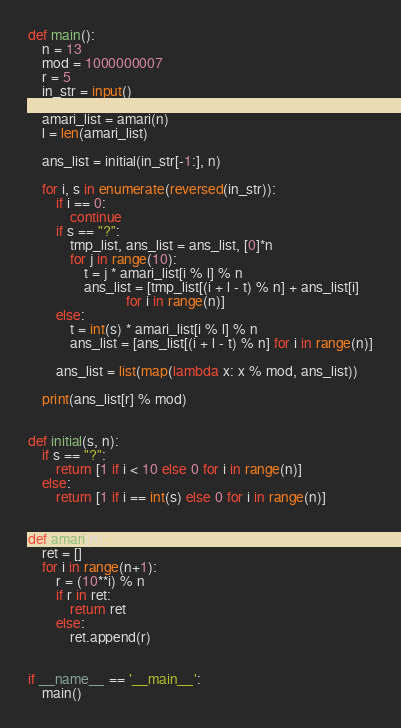Convert code to text. <code><loc_0><loc_0><loc_500><loc_500><_Python_>def main():
    n = 13
    mod = 1000000007
    r = 5
    in_str = input()

    amari_list = amari(n)
    l = len(amari_list)

    ans_list = initial(in_str[-1:], n)

    for i, s in enumerate(reversed(in_str)):
        if i == 0:
            continue
        if s == "?":
            tmp_list, ans_list = ans_list, [0]*n
            for j in range(10):
                t = j * amari_list[i % l] % n
                ans_list = [tmp_list[(i + l - t) % n] + ans_list[i]
                            for i in range(n)]
        else:
            t = int(s) * amari_list[i % l] % n
            ans_list = [ans_list[(i + l - t) % n] for i in range(n)]

        ans_list = list(map(lambda x: x % mod, ans_list))

    print(ans_list[r] % mod)


def initial(s, n):
    if s == "?":
        return [1 if i < 10 else 0 for i in range(n)]
    else:
        return [1 if i == int(s) else 0 for i in range(n)]


def amari(n):
    ret = []
    for i in range(n+1):
        r = (10**i) % n
        if r in ret:
            return ret
        else:
            ret.append(r)


if __name__ == '__main__':
    main()
</code> 